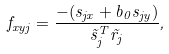Convert formula to latex. <formula><loc_0><loc_0><loc_500><loc_500>f _ { x y j } = \frac { - ( s _ { j x } + b _ { 0 } s _ { j y } ) } { \vec { s } ^ { T } _ { j } \vec { r } _ { j } } ,</formula> 